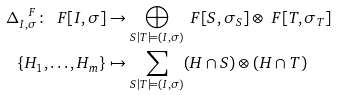<formula> <loc_0><loc_0><loc_500><loc_500>\Delta ^ { \ F } _ { I , \sigma } \colon \ F [ I , \sigma ] & \rightarrow \bigoplus _ { S | T \models ( I , \sigma ) } \ F [ S , \sigma _ { S } ] \otimes \ F [ T , \sigma _ { T } ] \\ \{ H _ { 1 } , \dots , H _ { m } \} & \mapsto \sum _ { S | T \models ( I , \sigma ) } ( H \cap S ) \otimes ( H \cap T )</formula> 